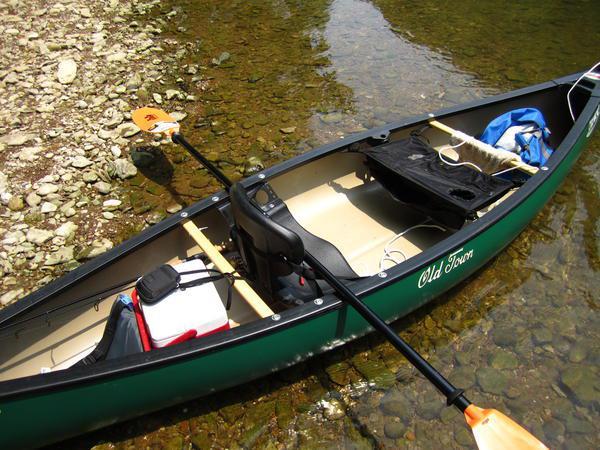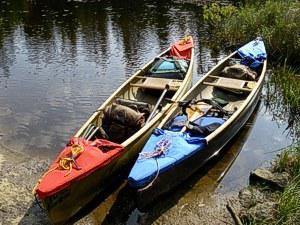The first image is the image on the left, the second image is the image on the right. Analyze the images presented: Is the assertion "At least one of the boats is not near water." valid? Answer yes or no. No. 